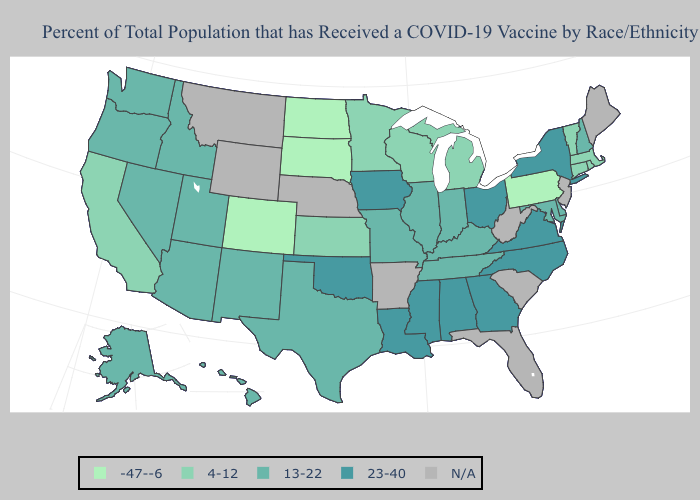Does the map have missing data?
Keep it brief. Yes. Name the states that have a value in the range 23-40?
Short answer required. Alabama, Georgia, Iowa, Louisiana, Mississippi, New York, North Carolina, Ohio, Oklahoma, Virginia. Does Missouri have the highest value in the USA?
Concise answer only. No. Does the first symbol in the legend represent the smallest category?
Concise answer only. Yes. Name the states that have a value in the range 23-40?
Short answer required. Alabama, Georgia, Iowa, Louisiana, Mississippi, New York, North Carolina, Ohio, Oklahoma, Virginia. What is the value of Maine?
Write a very short answer. N/A. What is the highest value in states that border Iowa?
Write a very short answer. 13-22. Name the states that have a value in the range N/A?
Keep it brief. Arkansas, Florida, Maine, Montana, Nebraska, New Jersey, South Carolina, West Virginia, Wyoming. Which states hav the highest value in the West?
Keep it brief. Alaska, Arizona, Hawaii, Idaho, Nevada, New Mexico, Oregon, Utah, Washington. Does Pennsylvania have the lowest value in the USA?
Be succinct. Yes. Among the states that border Nevada , does California have the highest value?
Short answer required. No. What is the value of Iowa?
Concise answer only. 23-40. Among the states that border Nevada , does Idaho have the highest value?
Answer briefly. Yes. 